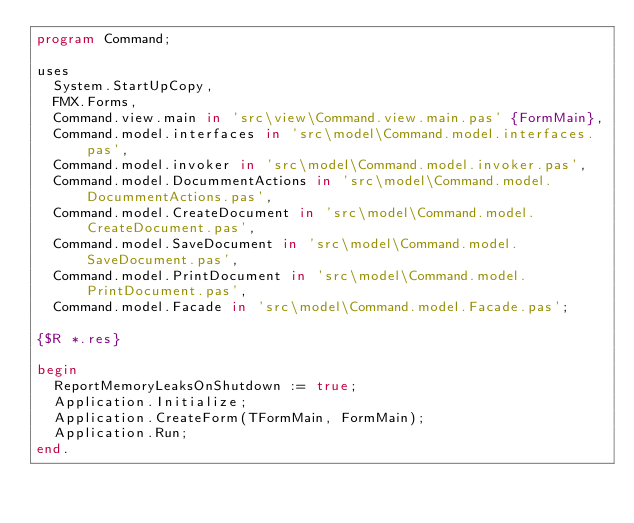<code> <loc_0><loc_0><loc_500><loc_500><_Pascal_>program Command;

uses
  System.StartUpCopy,
  FMX.Forms,
  Command.view.main in 'src\view\Command.view.main.pas' {FormMain},
  Command.model.interfaces in 'src\model\Command.model.interfaces.pas',
  Command.model.invoker in 'src\model\Command.model.invoker.pas',
  Command.model.DocummentActions in 'src\model\Command.model.DocummentActions.pas',
  Command.model.CreateDocument in 'src\model\Command.model.CreateDocument.pas',
  Command.model.SaveDocument in 'src\model\Command.model.SaveDocument.pas',
  Command.model.PrintDocument in 'src\model\Command.model.PrintDocument.pas',
  Command.model.Facade in 'src\model\Command.model.Facade.pas';

{$R *.res}

begin
  ReportMemoryLeaksOnShutdown := true;
  Application.Initialize;
  Application.CreateForm(TFormMain, FormMain);
  Application.Run;
end.
</code> 